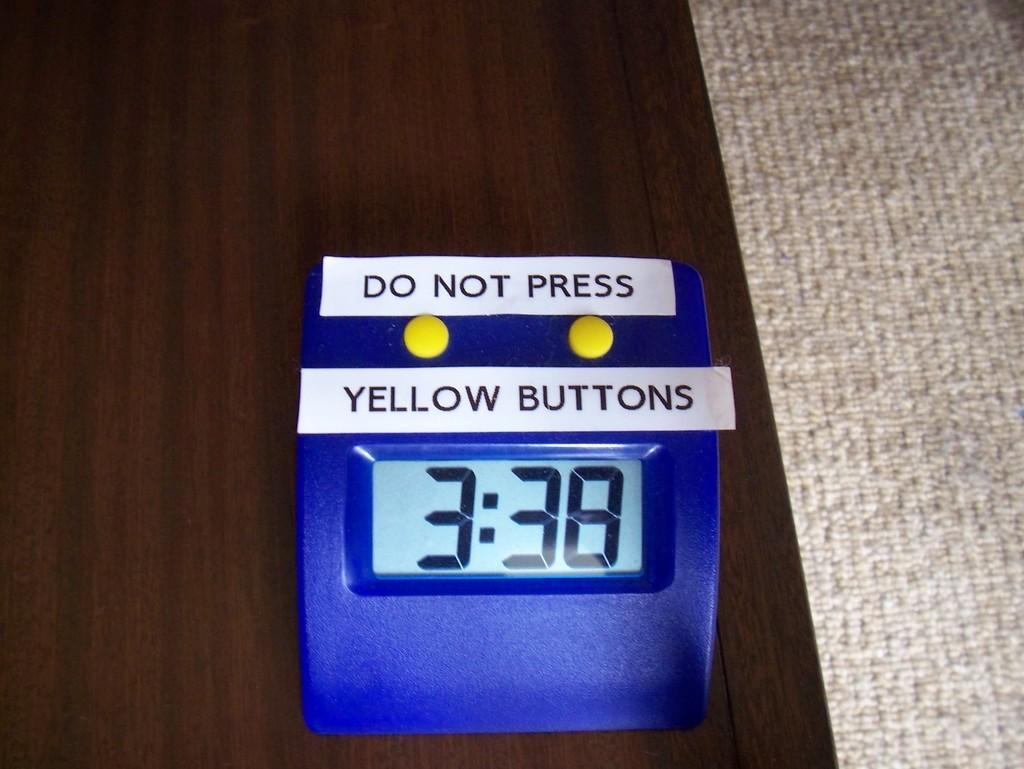<image>
Summarize the visual content of the image. A blue box which reads Do Not Press Yellow Buttons. 